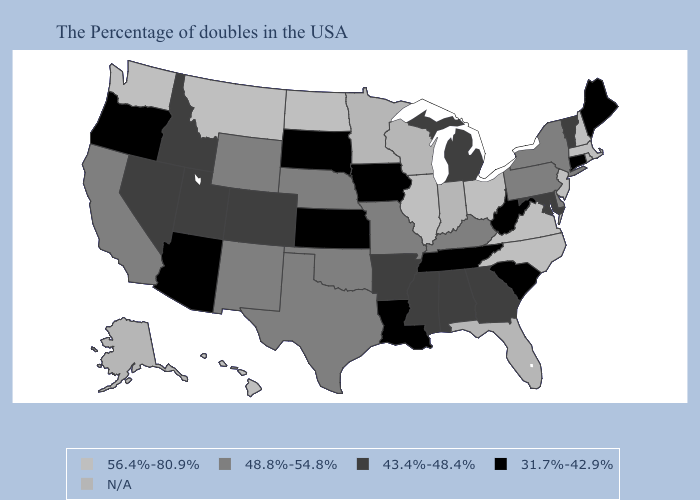Which states hav the highest value in the Northeast?
Be succinct. Massachusetts, New Hampshire, New Jersey. Name the states that have a value in the range 48.8%-54.8%?
Write a very short answer. New York, Delaware, Pennsylvania, Kentucky, Missouri, Nebraska, Oklahoma, Texas, Wyoming, New Mexico, California. Name the states that have a value in the range 43.4%-48.4%?
Keep it brief. Vermont, Maryland, Georgia, Michigan, Alabama, Mississippi, Arkansas, Colorado, Utah, Idaho, Nevada. Among the states that border Texas , does Louisiana have the lowest value?
Answer briefly. Yes. Does Tennessee have the lowest value in the USA?
Keep it brief. Yes. What is the value of West Virginia?
Concise answer only. 31.7%-42.9%. Does the map have missing data?
Write a very short answer. Yes. Name the states that have a value in the range 43.4%-48.4%?
Be succinct. Vermont, Maryland, Georgia, Michigan, Alabama, Mississippi, Arkansas, Colorado, Utah, Idaho, Nevada. What is the value of Connecticut?
Give a very brief answer. 31.7%-42.9%. Among the states that border Arizona , which have the lowest value?
Be succinct. Colorado, Utah, Nevada. Does Kansas have the lowest value in the USA?
Keep it brief. Yes. 